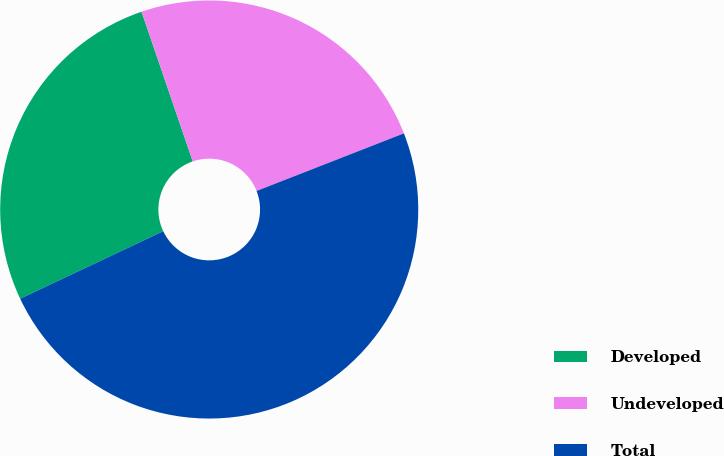<chart> <loc_0><loc_0><loc_500><loc_500><pie_chart><fcel>Developed<fcel>Undeveloped<fcel>Total<nl><fcel>26.77%<fcel>24.31%<fcel>48.91%<nl></chart> 